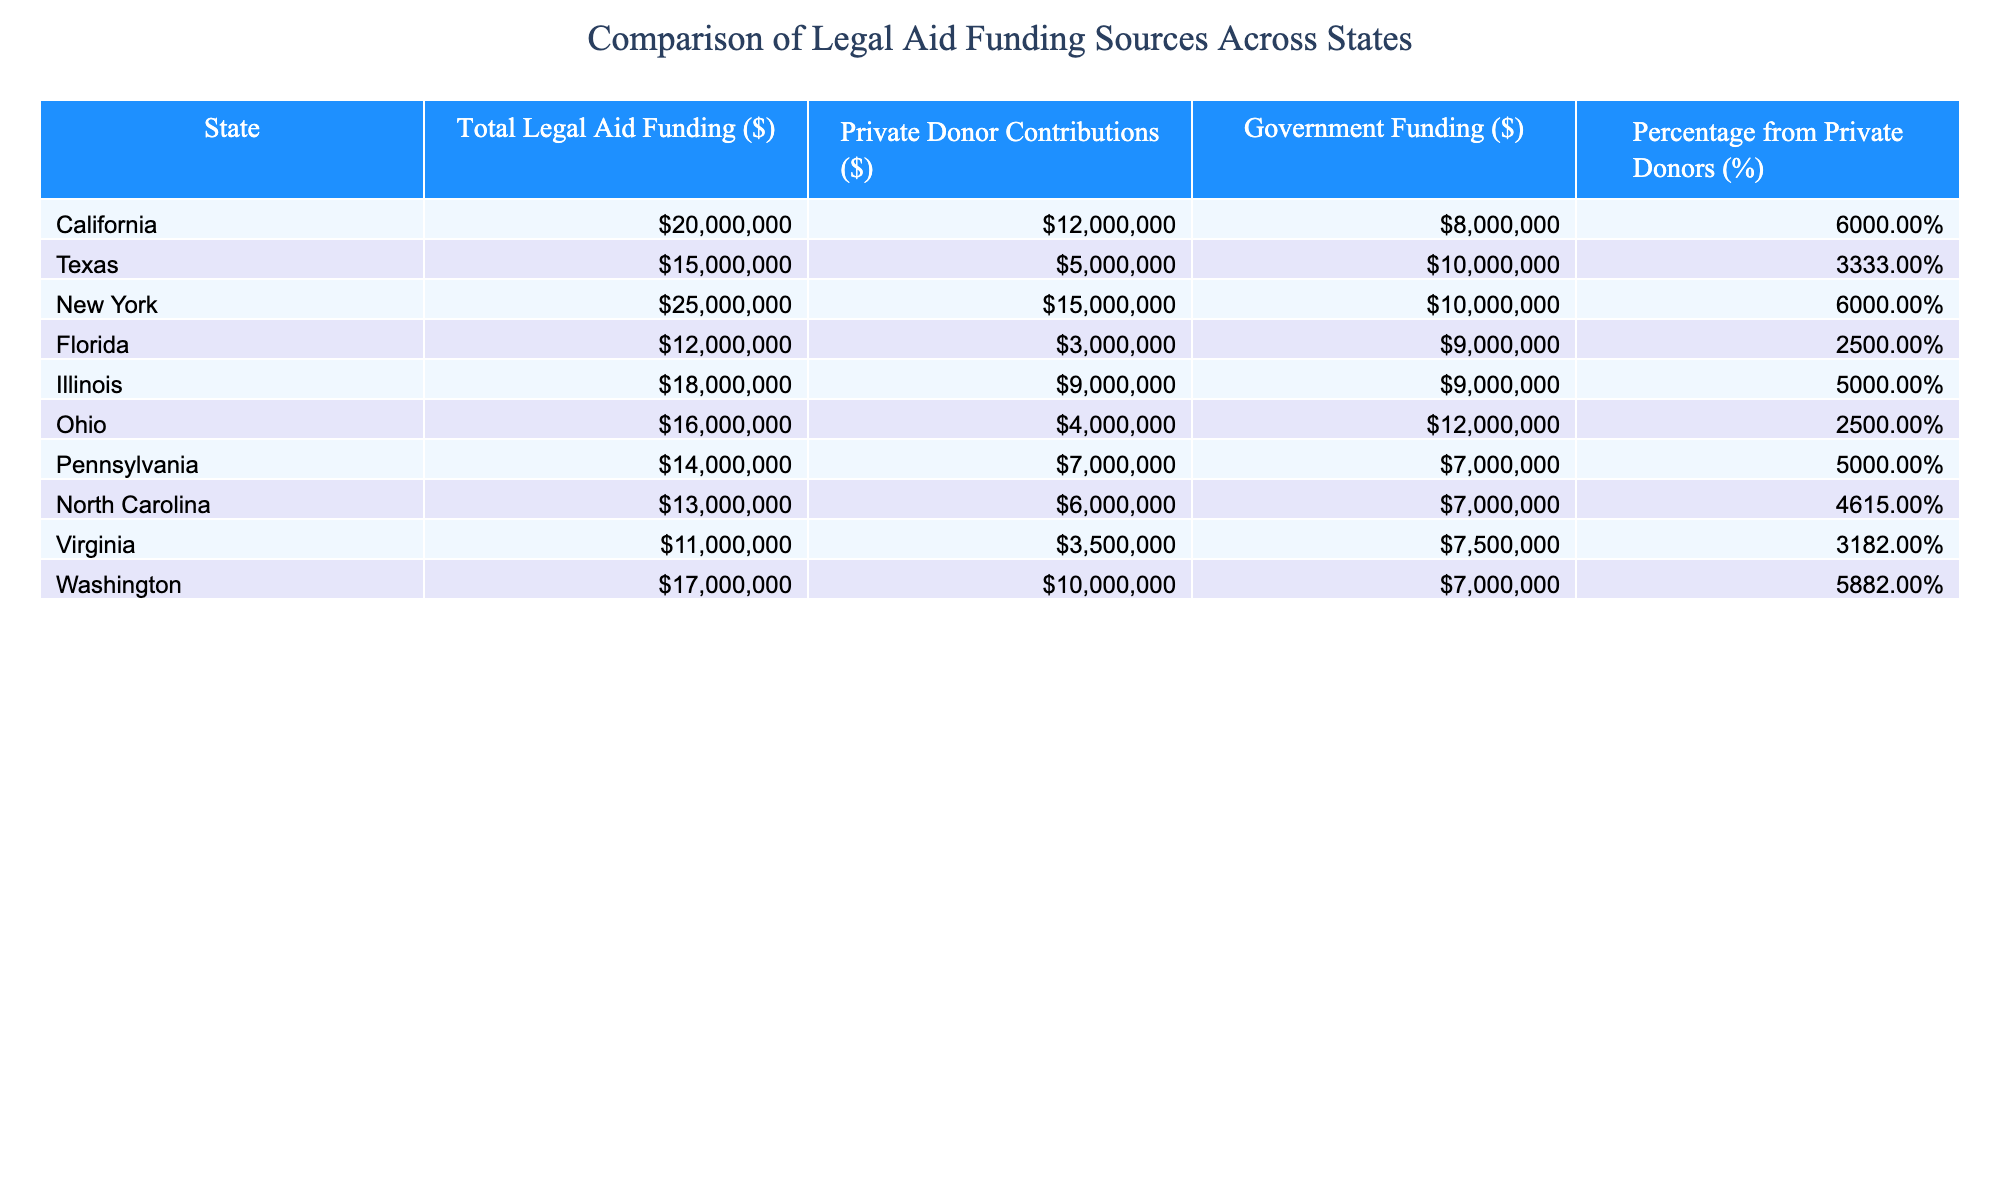What is the total legal aid funding for New York? The table shows that the total legal aid funding for New York is explicitly stated in the second column, which lists it as 25000000 dollars.
Answer: 25000000 What percentage of legal aid funding in California comes from private donors? Looking at the table under the "Percentage from Private Donors (%)" column for California, it is clear that the percentage from private donors is noted as 60%.
Answer: 60% Which state has the highest private donor contributions, and what is the amount? Examining the "Private Donor Contributions ($)" column, New York has the highest contribution of 15000000 dollars.
Answer: New York, 15000000 Calculate the average government funding across all states. To find the average, sum up all government funding amounts (8000000 + 10000000 + 10000000 + 9000000 + 9000000 + 12000000 + 7000000 + 7000000 + 7500000 + 7000000 = 86000000) and divide by the number of states (10), which gives an average of 8600000.
Answer: 8600000 Is the private donor contribution in Florida greater than the government funding? In the table, Florida's private donor contributions are 3000000 dollars and government funding is 9000000 dollars. Comparing these amounts shows that private contributions are less than government funding.
Answer: No Which state has the most balanced funding sources, where government and private funding are equal? By scanning the table, Illinois and Pennsylvania both have equal funding from private and government sources at 9000000 dollars.
Answer: Illinois and Pennsylvania What is the total private donor funding from all states listed? To calculate the total private donor contributions, sum all values in the "Private Donor Contributions ($)" column (12000000 + 5000000 + 15000000 + 3000000 + 9000000 + 4000000 + 7000000 + 6000000 + 3500000 + 10000000 = 69000000) for a grand total of 69000000 dollars.
Answer: 69000000 Which state has the smallest percentage of funding from private donors? From the "Percentage from Private Donors (%)" column, Florida shows the lowest percentage at 25%.
Answer: Florida Does any state have a total legal aid funding exceeding 20000000 dollars? By reviewing the "Total Legal Aid Funding ($)" column, both New York and California have amounts that exceed 20000000 dollars, confirming that there are states with more than this amount.
Answer: Yes 